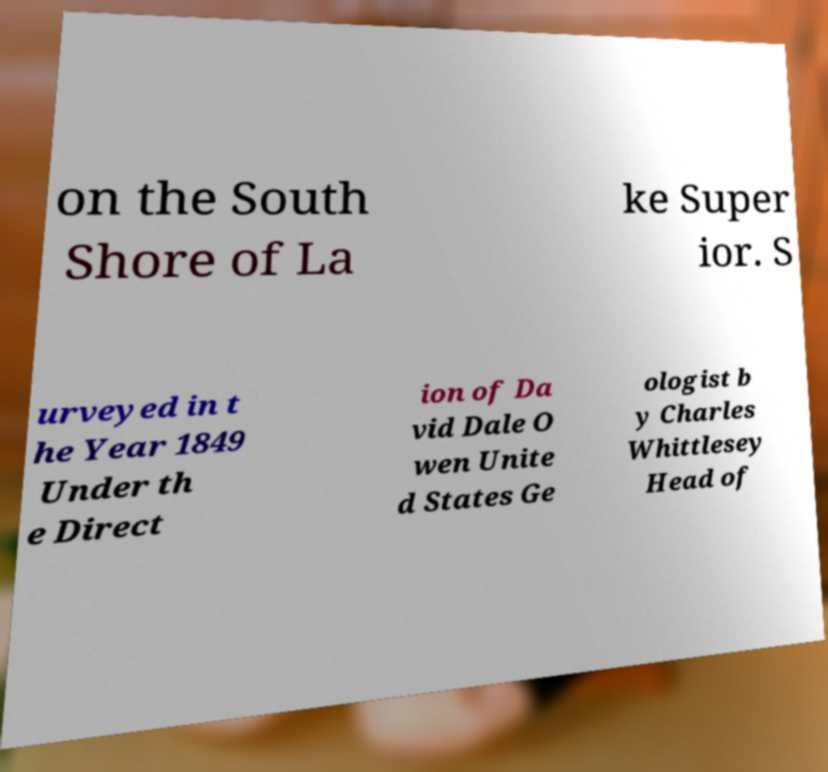What messages or text are displayed in this image? I need them in a readable, typed format. on the South Shore of La ke Super ior. S urveyed in t he Year 1849 Under th e Direct ion of Da vid Dale O wen Unite d States Ge ologist b y Charles Whittlesey Head of 